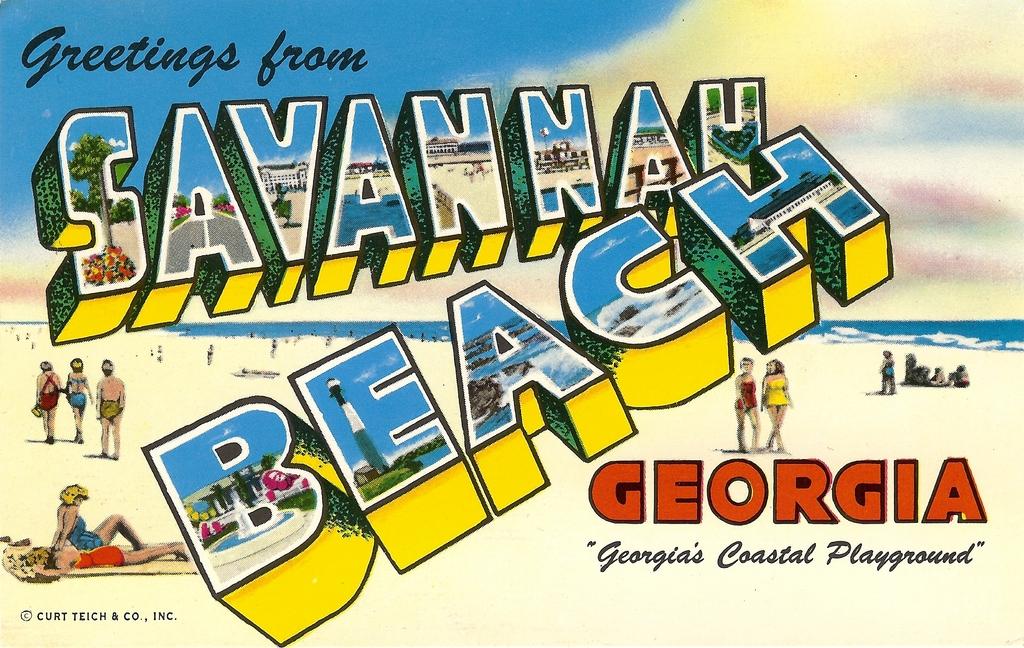Which beach is the post card from?
Provide a succinct answer. Savannah beach. What state is this beach in?
Offer a very short reply. Georgia. 